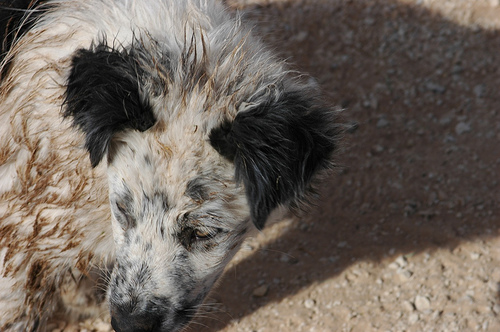<image>
Is there a dog on the earth? Yes. Looking at the image, I can see the dog is positioned on top of the earth, with the earth providing support. 